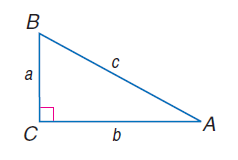Answer the mathemtical geometry problem and directly provide the correct option letter.
Question: a = 8, b = 15, and c = 17, find \sin A.
Choices: A: 0.30 B: 0.47 C: 0.53 D: 0.70 B 